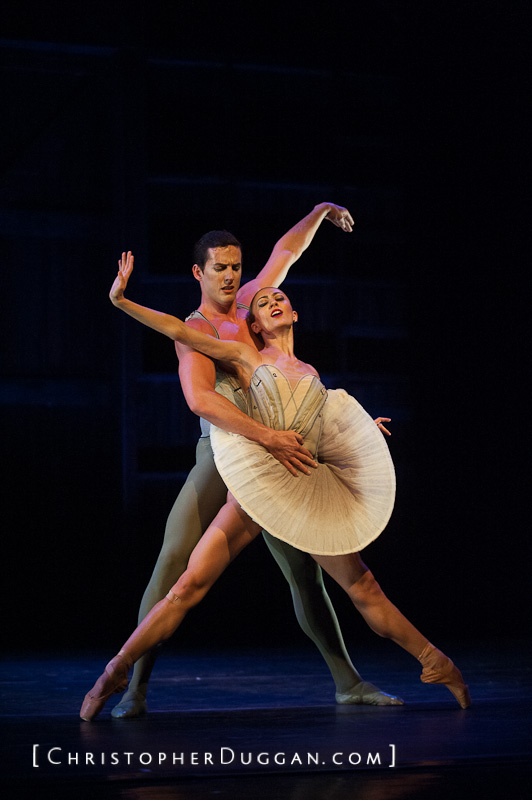What does the dancers' body language convey about the narrative or emotion of the performance? The dancers' body language powerfully conveys a sense of elegance, trust, and an intimate connection that hints at a romantic narrative. The male dancer's supportive touch and focused expression suggest a protective and guiding role, illuminating a deep bond and dependability. Meanwhile, the female dancer's lifted leg, arched back, and serene facial expression evoke grace, freedom, and a harmonious union. Their synchronized, fluid movements, combined with the gentle yet compelling contact between them, narrate a story of profound connection and mutual respect between the characters they represent. Overall, their expressive postures and interactions draw the audience into a tale of love, support, and unity. 